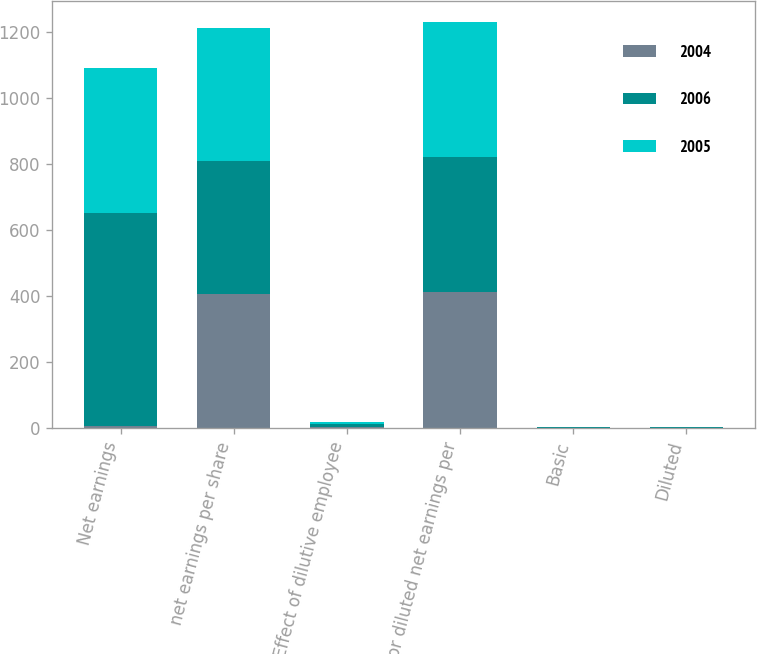<chart> <loc_0><loc_0><loc_500><loc_500><stacked_bar_chart><ecel><fcel>Net earnings<fcel>net earnings per share<fcel>Effect of dilutive employee<fcel>for diluted net earnings per<fcel>Basic<fcel>Diluted<nl><fcel>2004<fcel>8.1<fcel>406.5<fcel>5.3<fcel>411.8<fcel>1.91<fcel>1.89<nl><fcel>2006<fcel>643.6<fcel>403.7<fcel>7.1<fcel>410.8<fcel>1.59<fcel>1.57<nl><fcel>2005<fcel>440<fcel>401.2<fcel>8.1<fcel>409.3<fcel>1.1<fcel>1.08<nl></chart> 